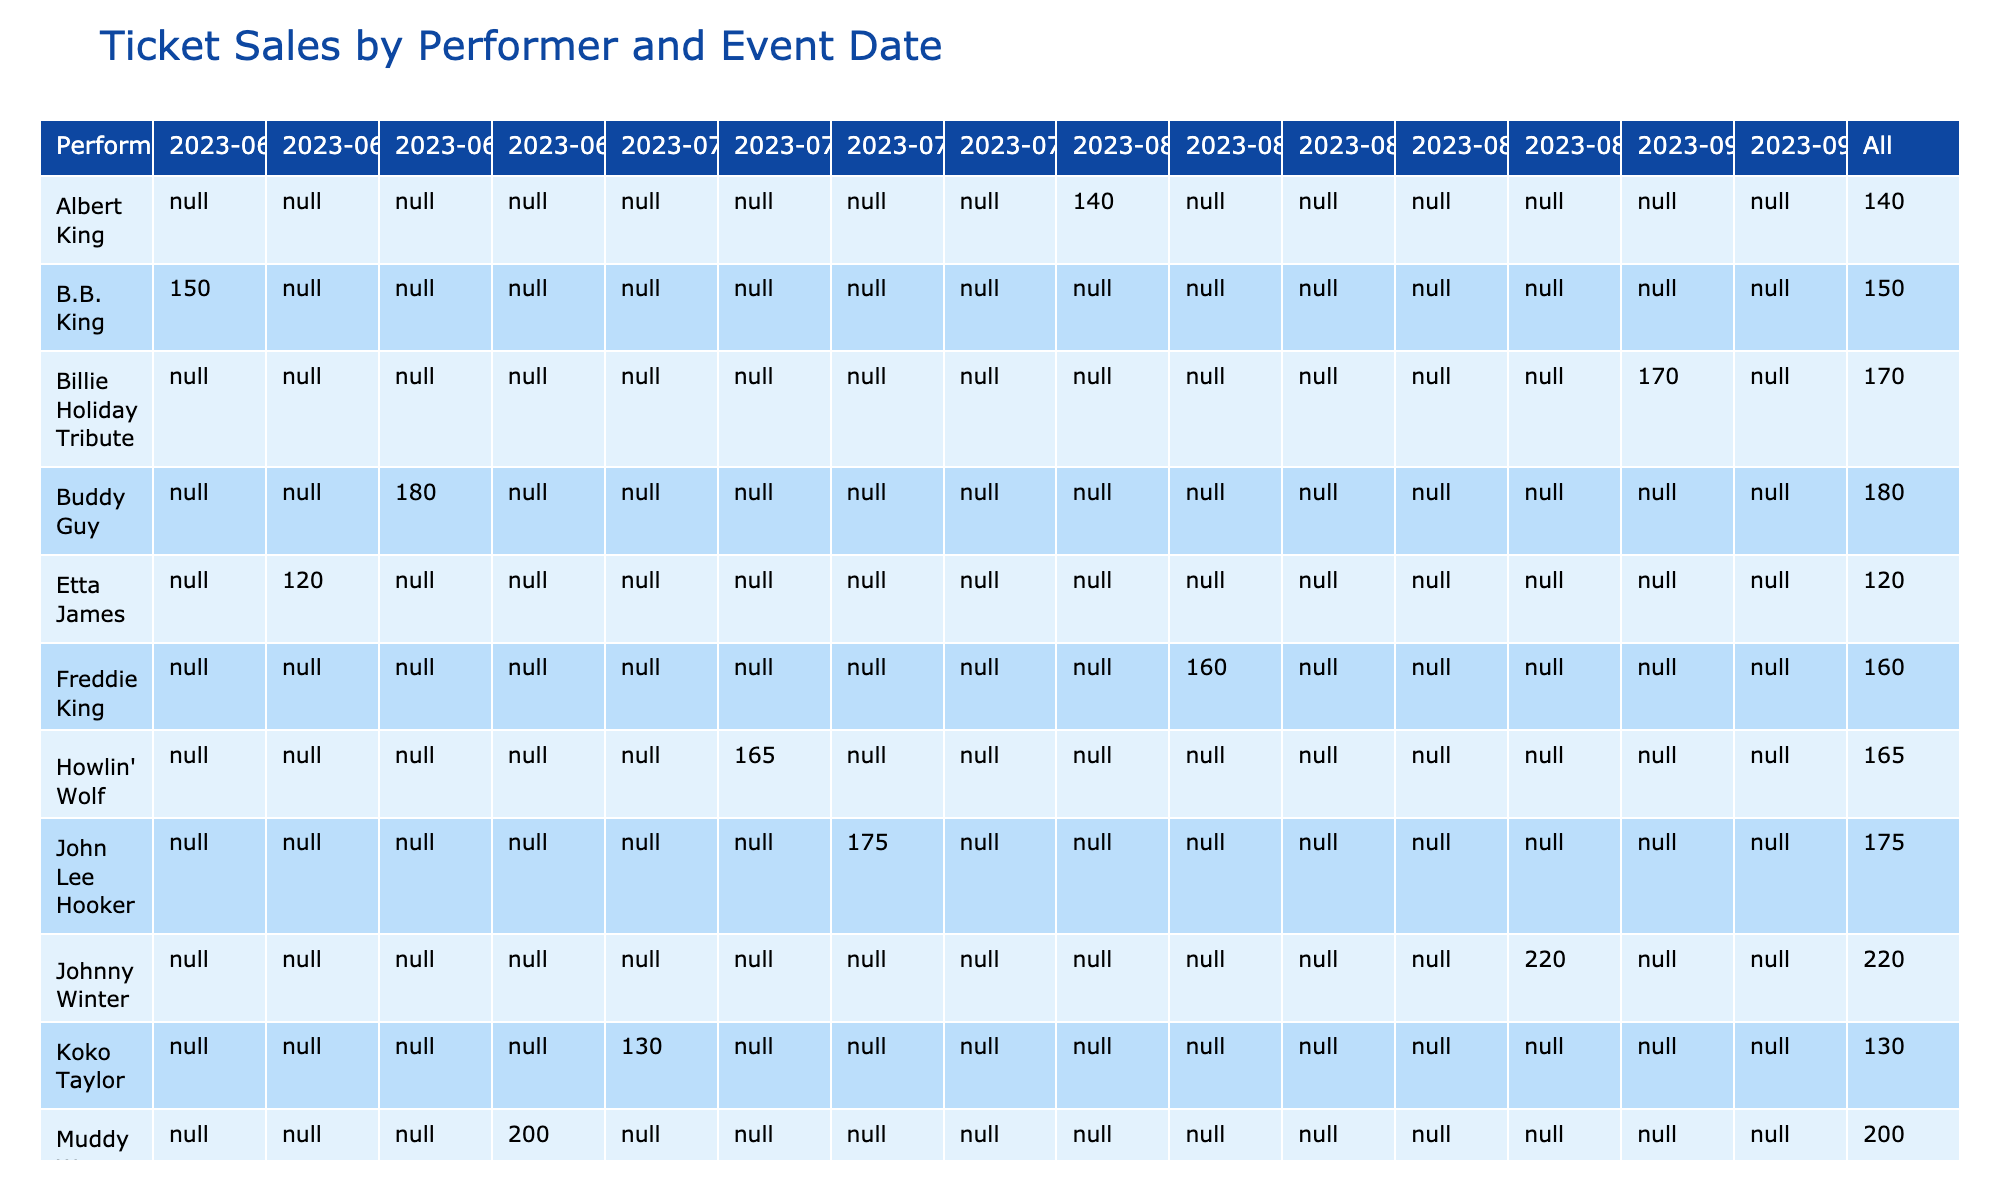What were the ticket sales for Johnny Winter on 2023-08-28? From the table, the row corresponding to Johnny Winter shows a ticket sales figure of 220 for the event date 2023-08-28.
Answer: 220 Which performer had the highest ticket sales? By scanning through the ticket sales values in the table, it appears that Johnny Winter has the highest ticket sales of 220.
Answer: Johnny Winter What are the total ticket sales for the month of July? The months of July include event dates 2023-07-03 (130), 2023-07-10 (165), and 2023-07-17 (175). Summing these values: 130 + 165 + 175 = 470.
Answer: 470 Did T-Bone Walker have ticket sales greater than 150? Looking at the ticket sales for T-Bone Walker, the value is 150, which is not greater than 150, so the answer is no.
Answer: No What is the average ticket sales for performers in August? The August ticket sales include 140 (Albert King), 160 (Freddie King), 150 (T-Bone Walker), 110 (Sonny Boy Williamson), and 220 (Johnny Winter). Adding these gives us a total of 780. There are 5 performers, so the average is 780 / 5 = 156.
Answer: 156 Which performer had ticket sales between 160 and 180? Scanning through the table, Howlin' Wolf had ticket sales of 165 and John Lee Hooker had ticket sales of 175, both of which are between 160 and 180.
Answer: Howlin' Wolf, John Lee Hooker How many performers had ticket sales of less than 150? By checking each row, Sonny Boy Williamson had ticket sales of 110 and Albert King had ticket sales of 140. Thus, there were 2 performers with ticket sales below 150.
Answer: 2 What are the ticket sales differences between the highest and lowest selling performers? The highest selling performer is Johnny Winter with 220 ticket sales and the lowest is Sonny Boy Williamson with 110 ticket sales. Therefore, the difference is 220 - 110 = 110.
Answer: 110 How many different performers were featured in September? The ticket sales data shows 2 performers for the month of September: Billie Holiday Tribute and Robert Johnson Revival, as evidenced by the rows for 2023-09-04 and 2023-09-11.
Answer: 2 